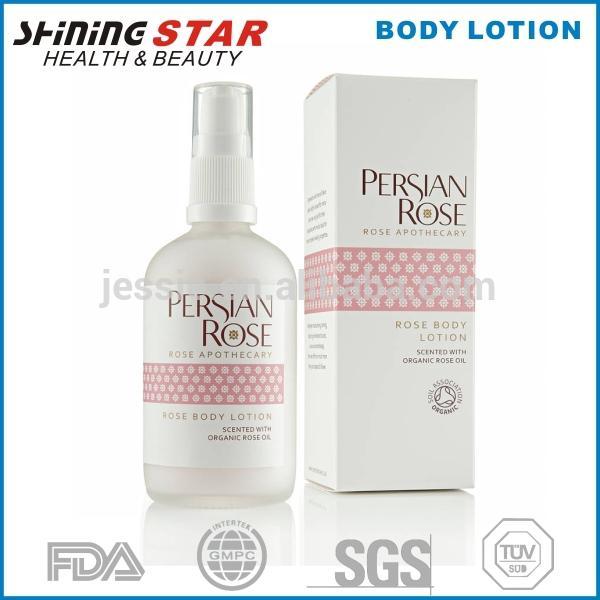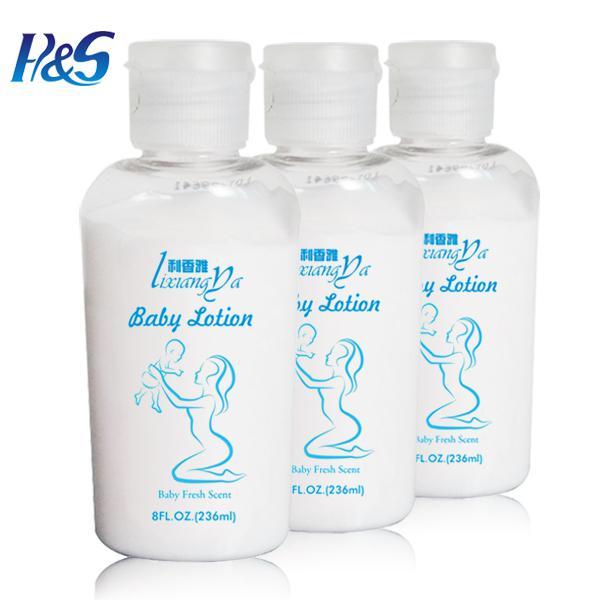The first image is the image on the left, the second image is the image on the right. Assess this claim about the two images: "The right image shows an angled row of at least three lotion products.". Correct or not? Answer yes or no. Yes. 